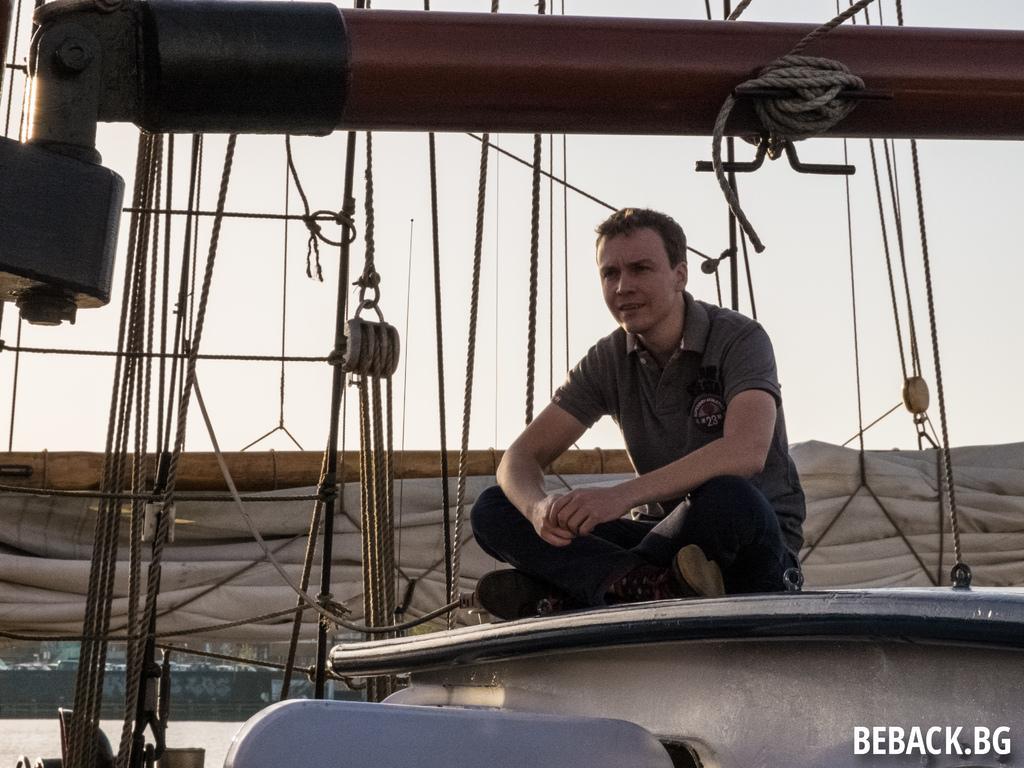Can you describe this image briefly? There is a man sitting on something. In the back there are ropes. In the right bottom corner there is a watermark. 